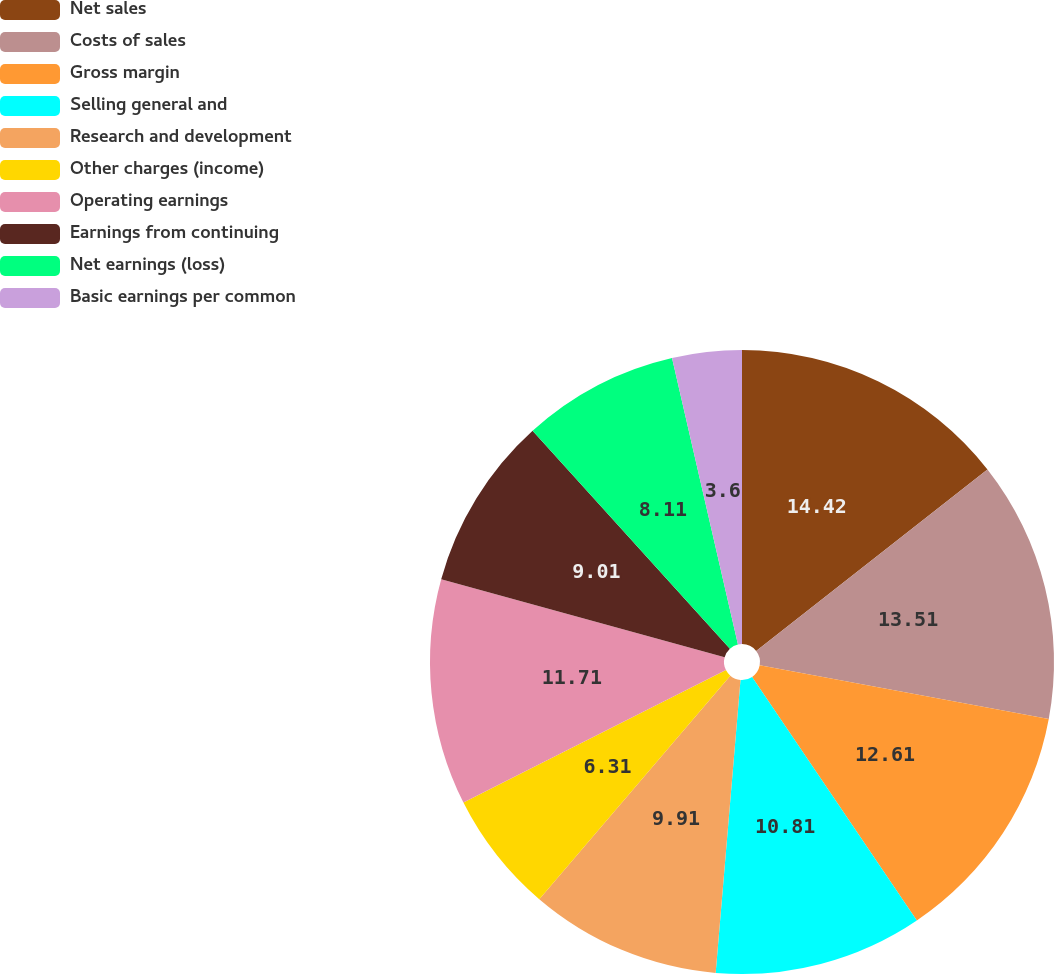Convert chart. <chart><loc_0><loc_0><loc_500><loc_500><pie_chart><fcel>Net sales<fcel>Costs of sales<fcel>Gross margin<fcel>Selling general and<fcel>Research and development<fcel>Other charges (income)<fcel>Operating earnings<fcel>Earnings from continuing<fcel>Net earnings (loss)<fcel>Basic earnings per common<nl><fcel>14.41%<fcel>13.51%<fcel>12.61%<fcel>10.81%<fcel>9.91%<fcel>6.31%<fcel>11.71%<fcel>9.01%<fcel>8.11%<fcel>3.6%<nl></chart> 